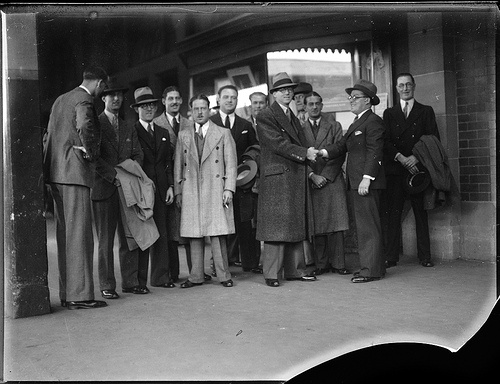Describe the objects in this image and their specific colors. I can see people in black, gray, and lightgray tones, people in black, gray, darkgray, and lightgray tones, people in black, gray, and lightgray tones, people in black, gray, darkgray, and lightgray tones, and people in black, darkgray, gray, and lightgray tones in this image. 